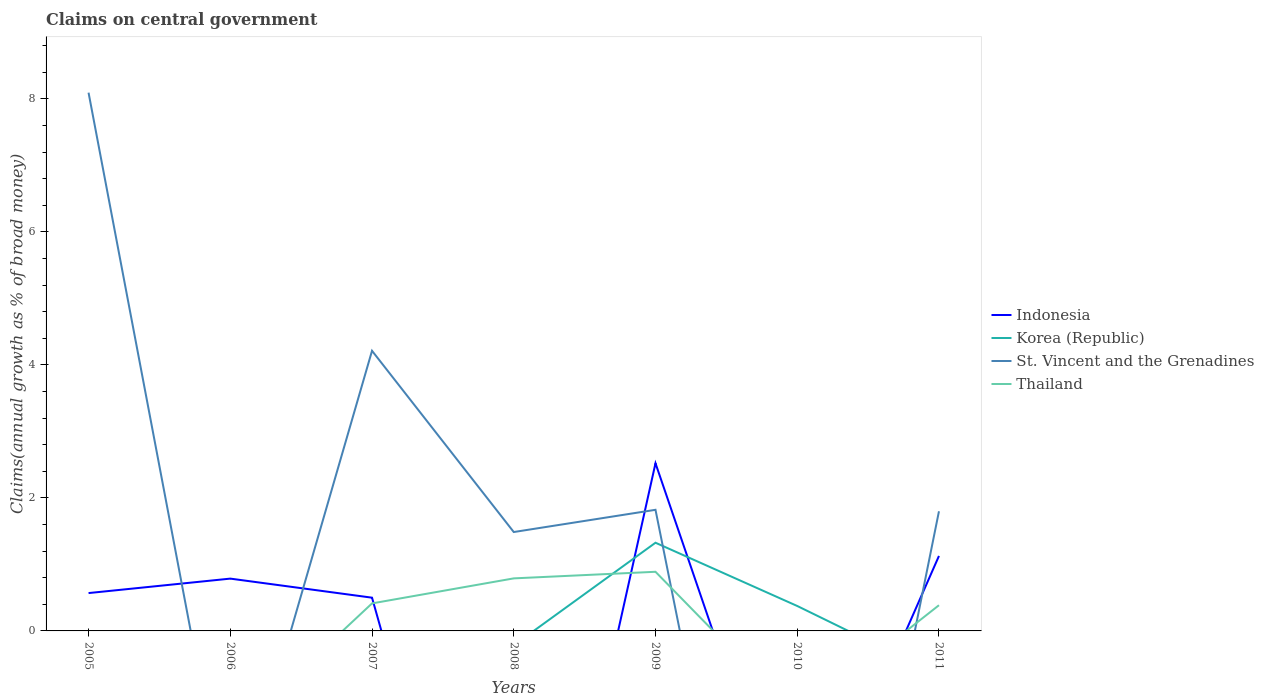How many different coloured lines are there?
Ensure brevity in your answer.  4. Is the number of lines equal to the number of legend labels?
Offer a very short reply. No. What is the total percentage of broad money claimed on centeral government in Indonesia in the graph?
Give a very brief answer. -0.63. What is the difference between the highest and the second highest percentage of broad money claimed on centeral government in Thailand?
Give a very brief answer. 0.89. Is the percentage of broad money claimed on centeral government in Indonesia strictly greater than the percentage of broad money claimed on centeral government in Thailand over the years?
Provide a succinct answer. No. How many lines are there?
Your answer should be compact. 4. How many years are there in the graph?
Provide a short and direct response. 7. What is the difference between two consecutive major ticks on the Y-axis?
Make the answer very short. 2. Are the values on the major ticks of Y-axis written in scientific E-notation?
Provide a short and direct response. No. Does the graph contain grids?
Your answer should be compact. No. How are the legend labels stacked?
Your response must be concise. Vertical. What is the title of the graph?
Ensure brevity in your answer.  Claims on central government. Does "Sao Tome and Principe" appear as one of the legend labels in the graph?
Your answer should be compact. No. What is the label or title of the Y-axis?
Offer a terse response. Claims(annual growth as % of broad money). What is the Claims(annual growth as % of broad money) in Indonesia in 2005?
Offer a very short reply. 0.57. What is the Claims(annual growth as % of broad money) in St. Vincent and the Grenadines in 2005?
Your answer should be very brief. 8.1. What is the Claims(annual growth as % of broad money) in Thailand in 2005?
Provide a succinct answer. 0. What is the Claims(annual growth as % of broad money) of Indonesia in 2006?
Your answer should be very brief. 0.79. What is the Claims(annual growth as % of broad money) in St. Vincent and the Grenadines in 2006?
Your response must be concise. 0. What is the Claims(annual growth as % of broad money) of Thailand in 2006?
Keep it short and to the point. 0. What is the Claims(annual growth as % of broad money) of Indonesia in 2007?
Keep it short and to the point. 0.5. What is the Claims(annual growth as % of broad money) of St. Vincent and the Grenadines in 2007?
Your answer should be compact. 4.21. What is the Claims(annual growth as % of broad money) in Thailand in 2007?
Provide a succinct answer. 0.41. What is the Claims(annual growth as % of broad money) of Indonesia in 2008?
Make the answer very short. 0. What is the Claims(annual growth as % of broad money) in St. Vincent and the Grenadines in 2008?
Make the answer very short. 1.49. What is the Claims(annual growth as % of broad money) in Thailand in 2008?
Provide a succinct answer. 0.79. What is the Claims(annual growth as % of broad money) in Indonesia in 2009?
Ensure brevity in your answer.  2.52. What is the Claims(annual growth as % of broad money) in Korea (Republic) in 2009?
Ensure brevity in your answer.  1.33. What is the Claims(annual growth as % of broad money) in St. Vincent and the Grenadines in 2009?
Offer a very short reply. 1.82. What is the Claims(annual growth as % of broad money) in Thailand in 2009?
Keep it short and to the point. 0.89. What is the Claims(annual growth as % of broad money) of Indonesia in 2010?
Your answer should be compact. 0. What is the Claims(annual growth as % of broad money) of Korea (Republic) in 2010?
Your response must be concise. 0.38. What is the Claims(annual growth as % of broad money) in Thailand in 2010?
Your response must be concise. 0. What is the Claims(annual growth as % of broad money) in Indonesia in 2011?
Provide a succinct answer. 1.13. What is the Claims(annual growth as % of broad money) in Korea (Republic) in 2011?
Offer a very short reply. 0. What is the Claims(annual growth as % of broad money) of St. Vincent and the Grenadines in 2011?
Give a very brief answer. 1.8. What is the Claims(annual growth as % of broad money) in Thailand in 2011?
Give a very brief answer. 0.39. Across all years, what is the maximum Claims(annual growth as % of broad money) of Indonesia?
Provide a succinct answer. 2.52. Across all years, what is the maximum Claims(annual growth as % of broad money) in Korea (Republic)?
Offer a terse response. 1.33. Across all years, what is the maximum Claims(annual growth as % of broad money) of St. Vincent and the Grenadines?
Give a very brief answer. 8.1. Across all years, what is the maximum Claims(annual growth as % of broad money) of Thailand?
Make the answer very short. 0.89. What is the total Claims(annual growth as % of broad money) of Indonesia in the graph?
Provide a short and direct response. 5.51. What is the total Claims(annual growth as % of broad money) of Korea (Republic) in the graph?
Your response must be concise. 1.7. What is the total Claims(annual growth as % of broad money) of St. Vincent and the Grenadines in the graph?
Provide a succinct answer. 17.42. What is the total Claims(annual growth as % of broad money) in Thailand in the graph?
Ensure brevity in your answer.  2.48. What is the difference between the Claims(annual growth as % of broad money) in Indonesia in 2005 and that in 2006?
Keep it short and to the point. -0.22. What is the difference between the Claims(annual growth as % of broad money) in Indonesia in 2005 and that in 2007?
Your response must be concise. 0.07. What is the difference between the Claims(annual growth as % of broad money) in St. Vincent and the Grenadines in 2005 and that in 2007?
Your answer should be compact. 3.88. What is the difference between the Claims(annual growth as % of broad money) in St. Vincent and the Grenadines in 2005 and that in 2008?
Give a very brief answer. 6.61. What is the difference between the Claims(annual growth as % of broad money) in Indonesia in 2005 and that in 2009?
Keep it short and to the point. -1.95. What is the difference between the Claims(annual growth as % of broad money) of St. Vincent and the Grenadines in 2005 and that in 2009?
Make the answer very short. 6.27. What is the difference between the Claims(annual growth as % of broad money) of Indonesia in 2005 and that in 2011?
Keep it short and to the point. -0.56. What is the difference between the Claims(annual growth as % of broad money) of St. Vincent and the Grenadines in 2005 and that in 2011?
Provide a succinct answer. 6.3. What is the difference between the Claims(annual growth as % of broad money) in Indonesia in 2006 and that in 2007?
Make the answer very short. 0.29. What is the difference between the Claims(annual growth as % of broad money) of Indonesia in 2006 and that in 2009?
Provide a succinct answer. -1.73. What is the difference between the Claims(annual growth as % of broad money) in Indonesia in 2006 and that in 2011?
Provide a succinct answer. -0.34. What is the difference between the Claims(annual growth as % of broad money) of St. Vincent and the Grenadines in 2007 and that in 2008?
Offer a terse response. 2.73. What is the difference between the Claims(annual growth as % of broad money) in Thailand in 2007 and that in 2008?
Give a very brief answer. -0.38. What is the difference between the Claims(annual growth as % of broad money) of Indonesia in 2007 and that in 2009?
Provide a short and direct response. -2.02. What is the difference between the Claims(annual growth as % of broad money) in St. Vincent and the Grenadines in 2007 and that in 2009?
Ensure brevity in your answer.  2.39. What is the difference between the Claims(annual growth as % of broad money) of Thailand in 2007 and that in 2009?
Provide a short and direct response. -0.48. What is the difference between the Claims(annual growth as % of broad money) of Indonesia in 2007 and that in 2011?
Make the answer very short. -0.63. What is the difference between the Claims(annual growth as % of broad money) of St. Vincent and the Grenadines in 2007 and that in 2011?
Offer a very short reply. 2.41. What is the difference between the Claims(annual growth as % of broad money) of Thailand in 2007 and that in 2011?
Provide a short and direct response. 0.03. What is the difference between the Claims(annual growth as % of broad money) of St. Vincent and the Grenadines in 2008 and that in 2009?
Make the answer very short. -0.33. What is the difference between the Claims(annual growth as % of broad money) in Thailand in 2008 and that in 2009?
Ensure brevity in your answer.  -0.1. What is the difference between the Claims(annual growth as % of broad money) of St. Vincent and the Grenadines in 2008 and that in 2011?
Offer a terse response. -0.31. What is the difference between the Claims(annual growth as % of broad money) of Thailand in 2008 and that in 2011?
Make the answer very short. 0.4. What is the difference between the Claims(annual growth as % of broad money) in Korea (Republic) in 2009 and that in 2010?
Provide a short and direct response. 0.95. What is the difference between the Claims(annual growth as % of broad money) in Indonesia in 2009 and that in 2011?
Keep it short and to the point. 1.39. What is the difference between the Claims(annual growth as % of broad money) in St. Vincent and the Grenadines in 2009 and that in 2011?
Your answer should be compact. 0.02. What is the difference between the Claims(annual growth as % of broad money) of Thailand in 2009 and that in 2011?
Offer a very short reply. 0.5. What is the difference between the Claims(annual growth as % of broad money) in Indonesia in 2005 and the Claims(annual growth as % of broad money) in St. Vincent and the Grenadines in 2007?
Provide a short and direct response. -3.64. What is the difference between the Claims(annual growth as % of broad money) in Indonesia in 2005 and the Claims(annual growth as % of broad money) in Thailand in 2007?
Offer a terse response. 0.16. What is the difference between the Claims(annual growth as % of broad money) in St. Vincent and the Grenadines in 2005 and the Claims(annual growth as % of broad money) in Thailand in 2007?
Your response must be concise. 7.68. What is the difference between the Claims(annual growth as % of broad money) in Indonesia in 2005 and the Claims(annual growth as % of broad money) in St. Vincent and the Grenadines in 2008?
Provide a short and direct response. -0.92. What is the difference between the Claims(annual growth as % of broad money) in Indonesia in 2005 and the Claims(annual growth as % of broad money) in Thailand in 2008?
Ensure brevity in your answer.  -0.22. What is the difference between the Claims(annual growth as % of broad money) in St. Vincent and the Grenadines in 2005 and the Claims(annual growth as % of broad money) in Thailand in 2008?
Offer a very short reply. 7.3. What is the difference between the Claims(annual growth as % of broad money) in Indonesia in 2005 and the Claims(annual growth as % of broad money) in Korea (Republic) in 2009?
Your answer should be compact. -0.76. What is the difference between the Claims(annual growth as % of broad money) of Indonesia in 2005 and the Claims(annual growth as % of broad money) of St. Vincent and the Grenadines in 2009?
Make the answer very short. -1.25. What is the difference between the Claims(annual growth as % of broad money) in Indonesia in 2005 and the Claims(annual growth as % of broad money) in Thailand in 2009?
Make the answer very short. -0.32. What is the difference between the Claims(annual growth as % of broad money) of St. Vincent and the Grenadines in 2005 and the Claims(annual growth as % of broad money) of Thailand in 2009?
Give a very brief answer. 7.21. What is the difference between the Claims(annual growth as % of broad money) of Indonesia in 2005 and the Claims(annual growth as % of broad money) of Korea (Republic) in 2010?
Your response must be concise. 0.19. What is the difference between the Claims(annual growth as % of broad money) in Indonesia in 2005 and the Claims(annual growth as % of broad money) in St. Vincent and the Grenadines in 2011?
Ensure brevity in your answer.  -1.23. What is the difference between the Claims(annual growth as % of broad money) in Indonesia in 2005 and the Claims(annual growth as % of broad money) in Thailand in 2011?
Give a very brief answer. 0.18. What is the difference between the Claims(annual growth as % of broad money) of St. Vincent and the Grenadines in 2005 and the Claims(annual growth as % of broad money) of Thailand in 2011?
Provide a short and direct response. 7.71. What is the difference between the Claims(annual growth as % of broad money) of Indonesia in 2006 and the Claims(annual growth as % of broad money) of St. Vincent and the Grenadines in 2007?
Your response must be concise. -3.43. What is the difference between the Claims(annual growth as % of broad money) of Indonesia in 2006 and the Claims(annual growth as % of broad money) of Thailand in 2007?
Ensure brevity in your answer.  0.37. What is the difference between the Claims(annual growth as % of broad money) of Indonesia in 2006 and the Claims(annual growth as % of broad money) of St. Vincent and the Grenadines in 2008?
Your answer should be very brief. -0.7. What is the difference between the Claims(annual growth as % of broad money) of Indonesia in 2006 and the Claims(annual growth as % of broad money) of Thailand in 2008?
Ensure brevity in your answer.  -0. What is the difference between the Claims(annual growth as % of broad money) of Indonesia in 2006 and the Claims(annual growth as % of broad money) of Korea (Republic) in 2009?
Ensure brevity in your answer.  -0.54. What is the difference between the Claims(annual growth as % of broad money) of Indonesia in 2006 and the Claims(annual growth as % of broad money) of St. Vincent and the Grenadines in 2009?
Make the answer very short. -1.03. What is the difference between the Claims(annual growth as % of broad money) in Indonesia in 2006 and the Claims(annual growth as % of broad money) in Thailand in 2009?
Provide a succinct answer. -0.1. What is the difference between the Claims(annual growth as % of broad money) of Indonesia in 2006 and the Claims(annual growth as % of broad money) of Korea (Republic) in 2010?
Provide a succinct answer. 0.41. What is the difference between the Claims(annual growth as % of broad money) of Indonesia in 2006 and the Claims(annual growth as % of broad money) of St. Vincent and the Grenadines in 2011?
Your answer should be compact. -1.01. What is the difference between the Claims(annual growth as % of broad money) of Indonesia in 2006 and the Claims(annual growth as % of broad money) of Thailand in 2011?
Make the answer very short. 0.4. What is the difference between the Claims(annual growth as % of broad money) of Indonesia in 2007 and the Claims(annual growth as % of broad money) of St. Vincent and the Grenadines in 2008?
Offer a terse response. -0.99. What is the difference between the Claims(annual growth as % of broad money) of Indonesia in 2007 and the Claims(annual growth as % of broad money) of Thailand in 2008?
Give a very brief answer. -0.29. What is the difference between the Claims(annual growth as % of broad money) in St. Vincent and the Grenadines in 2007 and the Claims(annual growth as % of broad money) in Thailand in 2008?
Your response must be concise. 3.42. What is the difference between the Claims(annual growth as % of broad money) of Indonesia in 2007 and the Claims(annual growth as % of broad money) of Korea (Republic) in 2009?
Make the answer very short. -0.83. What is the difference between the Claims(annual growth as % of broad money) of Indonesia in 2007 and the Claims(annual growth as % of broad money) of St. Vincent and the Grenadines in 2009?
Offer a terse response. -1.32. What is the difference between the Claims(annual growth as % of broad money) in Indonesia in 2007 and the Claims(annual growth as % of broad money) in Thailand in 2009?
Ensure brevity in your answer.  -0.39. What is the difference between the Claims(annual growth as % of broad money) of St. Vincent and the Grenadines in 2007 and the Claims(annual growth as % of broad money) of Thailand in 2009?
Ensure brevity in your answer.  3.32. What is the difference between the Claims(annual growth as % of broad money) in Indonesia in 2007 and the Claims(annual growth as % of broad money) in Korea (Republic) in 2010?
Ensure brevity in your answer.  0.12. What is the difference between the Claims(annual growth as % of broad money) in Indonesia in 2007 and the Claims(annual growth as % of broad money) in St. Vincent and the Grenadines in 2011?
Provide a short and direct response. -1.3. What is the difference between the Claims(annual growth as % of broad money) of Indonesia in 2007 and the Claims(annual growth as % of broad money) of Thailand in 2011?
Offer a terse response. 0.11. What is the difference between the Claims(annual growth as % of broad money) of St. Vincent and the Grenadines in 2007 and the Claims(annual growth as % of broad money) of Thailand in 2011?
Offer a terse response. 3.83. What is the difference between the Claims(annual growth as % of broad money) of St. Vincent and the Grenadines in 2008 and the Claims(annual growth as % of broad money) of Thailand in 2009?
Provide a succinct answer. 0.6. What is the difference between the Claims(annual growth as % of broad money) in St. Vincent and the Grenadines in 2008 and the Claims(annual growth as % of broad money) in Thailand in 2011?
Offer a terse response. 1.1. What is the difference between the Claims(annual growth as % of broad money) in Indonesia in 2009 and the Claims(annual growth as % of broad money) in Korea (Republic) in 2010?
Provide a short and direct response. 2.15. What is the difference between the Claims(annual growth as % of broad money) of Indonesia in 2009 and the Claims(annual growth as % of broad money) of St. Vincent and the Grenadines in 2011?
Your response must be concise. 0.72. What is the difference between the Claims(annual growth as % of broad money) of Indonesia in 2009 and the Claims(annual growth as % of broad money) of Thailand in 2011?
Ensure brevity in your answer.  2.14. What is the difference between the Claims(annual growth as % of broad money) of Korea (Republic) in 2009 and the Claims(annual growth as % of broad money) of St. Vincent and the Grenadines in 2011?
Provide a short and direct response. -0.47. What is the difference between the Claims(annual growth as % of broad money) in Korea (Republic) in 2009 and the Claims(annual growth as % of broad money) in Thailand in 2011?
Your response must be concise. 0.94. What is the difference between the Claims(annual growth as % of broad money) of St. Vincent and the Grenadines in 2009 and the Claims(annual growth as % of broad money) of Thailand in 2011?
Ensure brevity in your answer.  1.44. What is the difference between the Claims(annual growth as % of broad money) of Korea (Republic) in 2010 and the Claims(annual growth as % of broad money) of St. Vincent and the Grenadines in 2011?
Keep it short and to the point. -1.42. What is the difference between the Claims(annual growth as % of broad money) of Korea (Republic) in 2010 and the Claims(annual growth as % of broad money) of Thailand in 2011?
Your answer should be very brief. -0.01. What is the average Claims(annual growth as % of broad money) of Indonesia per year?
Your response must be concise. 0.79. What is the average Claims(annual growth as % of broad money) of Korea (Republic) per year?
Give a very brief answer. 0.24. What is the average Claims(annual growth as % of broad money) in St. Vincent and the Grenadines per year?
Give a very brief answer. 2.49. What is the average Claims(annual growth as % of broad money) of Thailand per year?
Give a very brief answer. 0.35. In the year 2005, what is the difference between the Claims(annual growth as % of broad money) in Indonesia and Claims(annual growth as % of broad money) in St. Vincent and the Grenadines?
Give a very brief answer. -7.53. In the year 2007, what is the difference between the Claims(annual growth as % of broad money) of Indonesia and Claims(annual growth as % of broad money) of St. Vincent and the Grenadines?
Offer a terse response. -3.71. In the year 2007, what is the difference between the Claims(annual growth as % of broad money) of Indonesia and Claims(annual growth as % of broad money) of Thailand?
Offer a terse response. 0.09. In the year 2007, what is the difference between the Claims(annual growth as % of broad money) of St. Vincent and the Grenadines and Claims(annual growth as % of broad money) of Thailand?
Your response must be concise. 3.8. In the year 2008, what is the difference between the Claims(annual growth as % of broad money) of St. Vincent and the Grenadines and Claims(annual growth as % of broad money) of Thailand?
Make the answer very short. 0.7. In the year 2009, what is the difference between the Claims(annual growth as % of broad money) of Indonesia and Claims(annual growth as % of broad money) of Korea (Republic)?
Offer a terse response. 1.2. In the year 2009, what is the difference between the Claims(annual growth as % of broad money) of Indonesia and Claims(annual growth as % of broad money) of St. Vincent and the Grenadines?
Keep it short and to the point. 0.7. In the year 2009, what is the difference between the Claims(annual growth as % of broad money) in Indonesia and Claims(annual growth as % of broad money) in Thailand?
Keep it short and to the point. 1.63. In the year 2009, what is the difference between the Claims(annual growth as % of broad money) in Korea (Republic) and Claims(annual growth as % of broad money) in St. Vincent and the Grenadines?
Keep it short and to the point. -0.5. In the year 2009, what is the difference between the Claims(annual growth as % of broad money) in Korea (Republic) and Claims(annual growth as % of broad money) in Thailand?
Make the answer very short. 0.44. In the year 2009, what is the difference between the Claims(annual growth as % of broad money) of St. Vincent and the Grenadines and Claims(annual growth as % of broad money) of Thailand?
Your response must be concise. 0.93. In the year 2011, what is the difference between the Claims(annual growth as % of broad money) of Indonesia and Claims(annual growth as % of broad money) of St. Vincent and the Grenadines?
Ensure brevity in your answer.  -0.67. In the year 2011, what is the difference between the Claims(annual growth as % of broad money) of Indonesia and Claims(annual growth as % of broad money) of Thailand?
Ensure brevity in your answer.  0.74. In the year 2011, what is the difference between the Claims(annual growth as % of broad money) of St. Vincent and the Grenadines and Claims(annual growth as % of broad money) of Thailand?
Provide a succinct answer. 1.41. What is the ratio of the Claims(annual growth as % of broad money) in Indonesia in 2005 to that in 2006?
Make the answer very short. 0.72. What is the ratio of the Claims(annual growth as % of broad money) in Indonesia in 2005 to that in 2007?
Your answer should be compact. 1.14. What is the ratio of the Claims(annual growth as % of broad money) of St. Vincent and the Grenadines in 2005 to that in 2007?
Ensure brevity in your answer.  1.92. What is the ratio of the Claims(annual growth as % of broad money) of St. Vincent and the Grenadines in 2005 to that in 2008?
Keep it short and to the point. 5.44. What is the ratio of the Claims(annual growth as % of broad money) in Indonesia in 2005 to that in 2009?
Provide a short and direct response. 0.23. What is the ratio of the Claims(annual growth as % of broad money) of St. Vincent and the Grenadines in 2005 to that in 2009?
Ensure brevity in your answer.  4.44. What is the ratio of the Claims(annual growth as % of broad money) of Indonesia in 2005 to that in 2011?
Offer a very short reply. 0.5. What is the ratio of the Claims(annual growth as % of broad money) of St. Vincent and the Grenadines in 2005 to that in 2011?
Your answer should be very brief. 4.5. What is the ratio of the Claims(annual growth as % of broad money) in Indonesia in 2006 to that in 2007?
Keep it short and to the point. 1.57. What is the ratio of the Claims(annual growth as % of broad money) in Indonesia in 2006 to that in 2009?
Give a very brief answer. 0.31. What is the ratio of the Claims(annual growth as % of broad money) of Indonesia in 2006 to that in 2011?
Provide a succinct answer. 0.7. What is the ratio of the Claims(annual growth as % of broad money) in St. Vincent and the Grenadines in 2007 to that in 2008?
Keep it short and to the point. 2.83. What is the ratio of the Claims(annual growth as % of broad money) in Thailand in 2007 to that in 2008?
Keep it short and to the point. 0.52. What is the ratio of the Claims(annual growth as % of broad money) of Indonesia in 2007 to that in 2009?
Ensure brevity in your answer.  0.2. What is the ratio of the Claims(annual growth as % of broad money) in St. Vincent and the Grenadines in 2007 to that in 2009?
Offer a very short reply. 2.31. What is the ratio of the Claims(annual growth as % of broad money) in Thailand in 2007 to that in 2009?
Provide a succinct answer. 0.47. What is the ratio of the Claims(annual growth as % of broad money) of Indonesia in 2007 to that in 2011?
Provide a succinct answer. 0.44. What is the ratio of the Claims(annual growth as % of broad money) in St. Vincent and the Grenadines in 2007 to that in 2011?
Ensure brevity in your answer.  2.34. What is the ratio of the Claims(annual growth as % of broad money) of Thailand in 2007 to that in 2011?
Ensure brevity in your answer.  1.07. What is the ratio of the Claims(annual growth as % of broad money) in St. Vincent and the Grenadines in 2008 to that in 2009?
Give a very brief answer. 0.82. What is the ratio of the Claims(annual growth as % of broad money) of Thailand in 2008 to that in 2009?
Provide a short and direct response. 0.89. What is the ratio of the Claims(annual growth as % of broad money) in St. Vincent and the Grenadines in 2008 to that in 2011?
Offer a very short reply. 0.83. What is the ratio of the Claims(annual growth as % of broad money) of Thailand in 2008 to that in 2011?
Your answer should be very brief. 2.04. What is the ratio of the Claims(annual growth as % of broad money) of Korea (Republic) in 2009 to that in 2010?
Make the answer very short. 3.54. What is the ratio of the Claims(annual growth as % of broad money) of Indonesia in 2009 to that in 2011?
Your answer should be very brief. 2.24. What is the ratio of the Claims(annual growth as % of broad money) of St. Vincent and the Grenadines in 2009 to that in 2011?
Offer a terse response. 1.01. What is the ratio of the Claims(annual growth as % of broad money) in Thailand in 2009 to that in 2011?
Your answer should be compact. 2.3. What is the difference between the highest and the second highest Claims(annual growth as % of broad money) in Indonesia?
Provide a succinct answer. 1.39. What is the difference between the highest and the second highest Claims(annual growth as % of broad money) in St. Vincent and the Grenadines?
Make the answer very short. 3.88. What is the difference between the highest and the second highest Claims(annual growth as % of broad money) in Thailand?
Keep it short and to the point. 0.1. What is the difference between the highest and the lowest Claims(annual growth as % of broad money) of Indonesia?
Your response must be concise. 2.52. What is the difference between the highest and the lowest Claims(annual growth as % of broad money) of Korea (Republic)?
Give a very brief answer. 1.33. What is the difference between the highest and the lowest Claims(annual growth as % of broad money) in St. Vincent and the Grenadines?
Give a very brief answer. 8.1. What is the difference between the highest and the lowest Claims(annual growth as % of broad money) in Thailand?
Give a very brief answer. 0.89. 